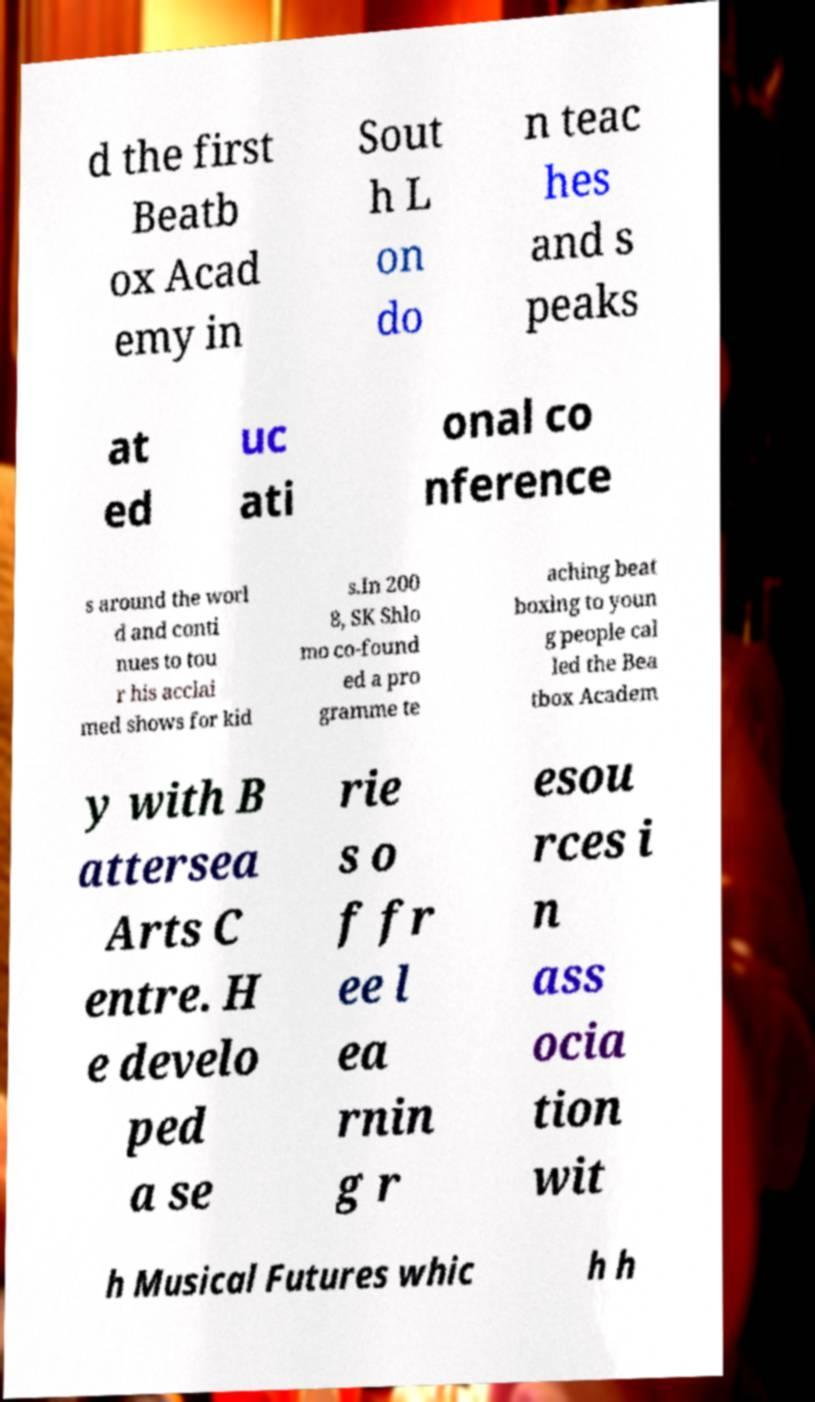Can you accurately transcribe the text from the provided image for me? d the first Beatb ox Acad emy in Sout h L on do n teac hes and s peaks at ed uc ati onal co nference s around the worl d and conti nues to tou r his acclai med shows for kid s.In 200 8, SK Shlo mo co-found ed a pro gramme te aching beat boxing to youn g people cal led the Bea tbox Academ y with B attersea Arts C entre. H e develo ped a se rie s o f fr ee l ea rnin g r esou rces i n ass ocia tion wit h Musical Futures whic h h 